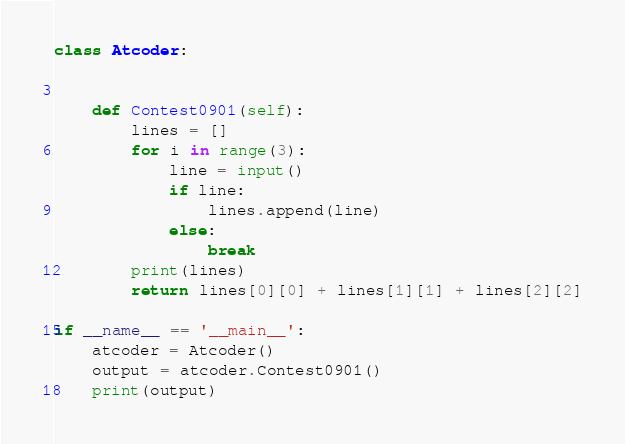Convert code to text. <code><loc_0><loc_0><loc_500><loc_500><_Python_>class Atcoder:


    def Contest0901(self):
        lines = []
        for i in range(3):
            line = input()
            if line:
                lines.append(line)
            else:
                break
        print(lines)
        return lines[0][0] + lines[1][1] + lines[2][2]

if __name__ == '__main__':
    atcoder = Atcoder()
    output = atcoder.Contest0901()
    print(output)</code> 